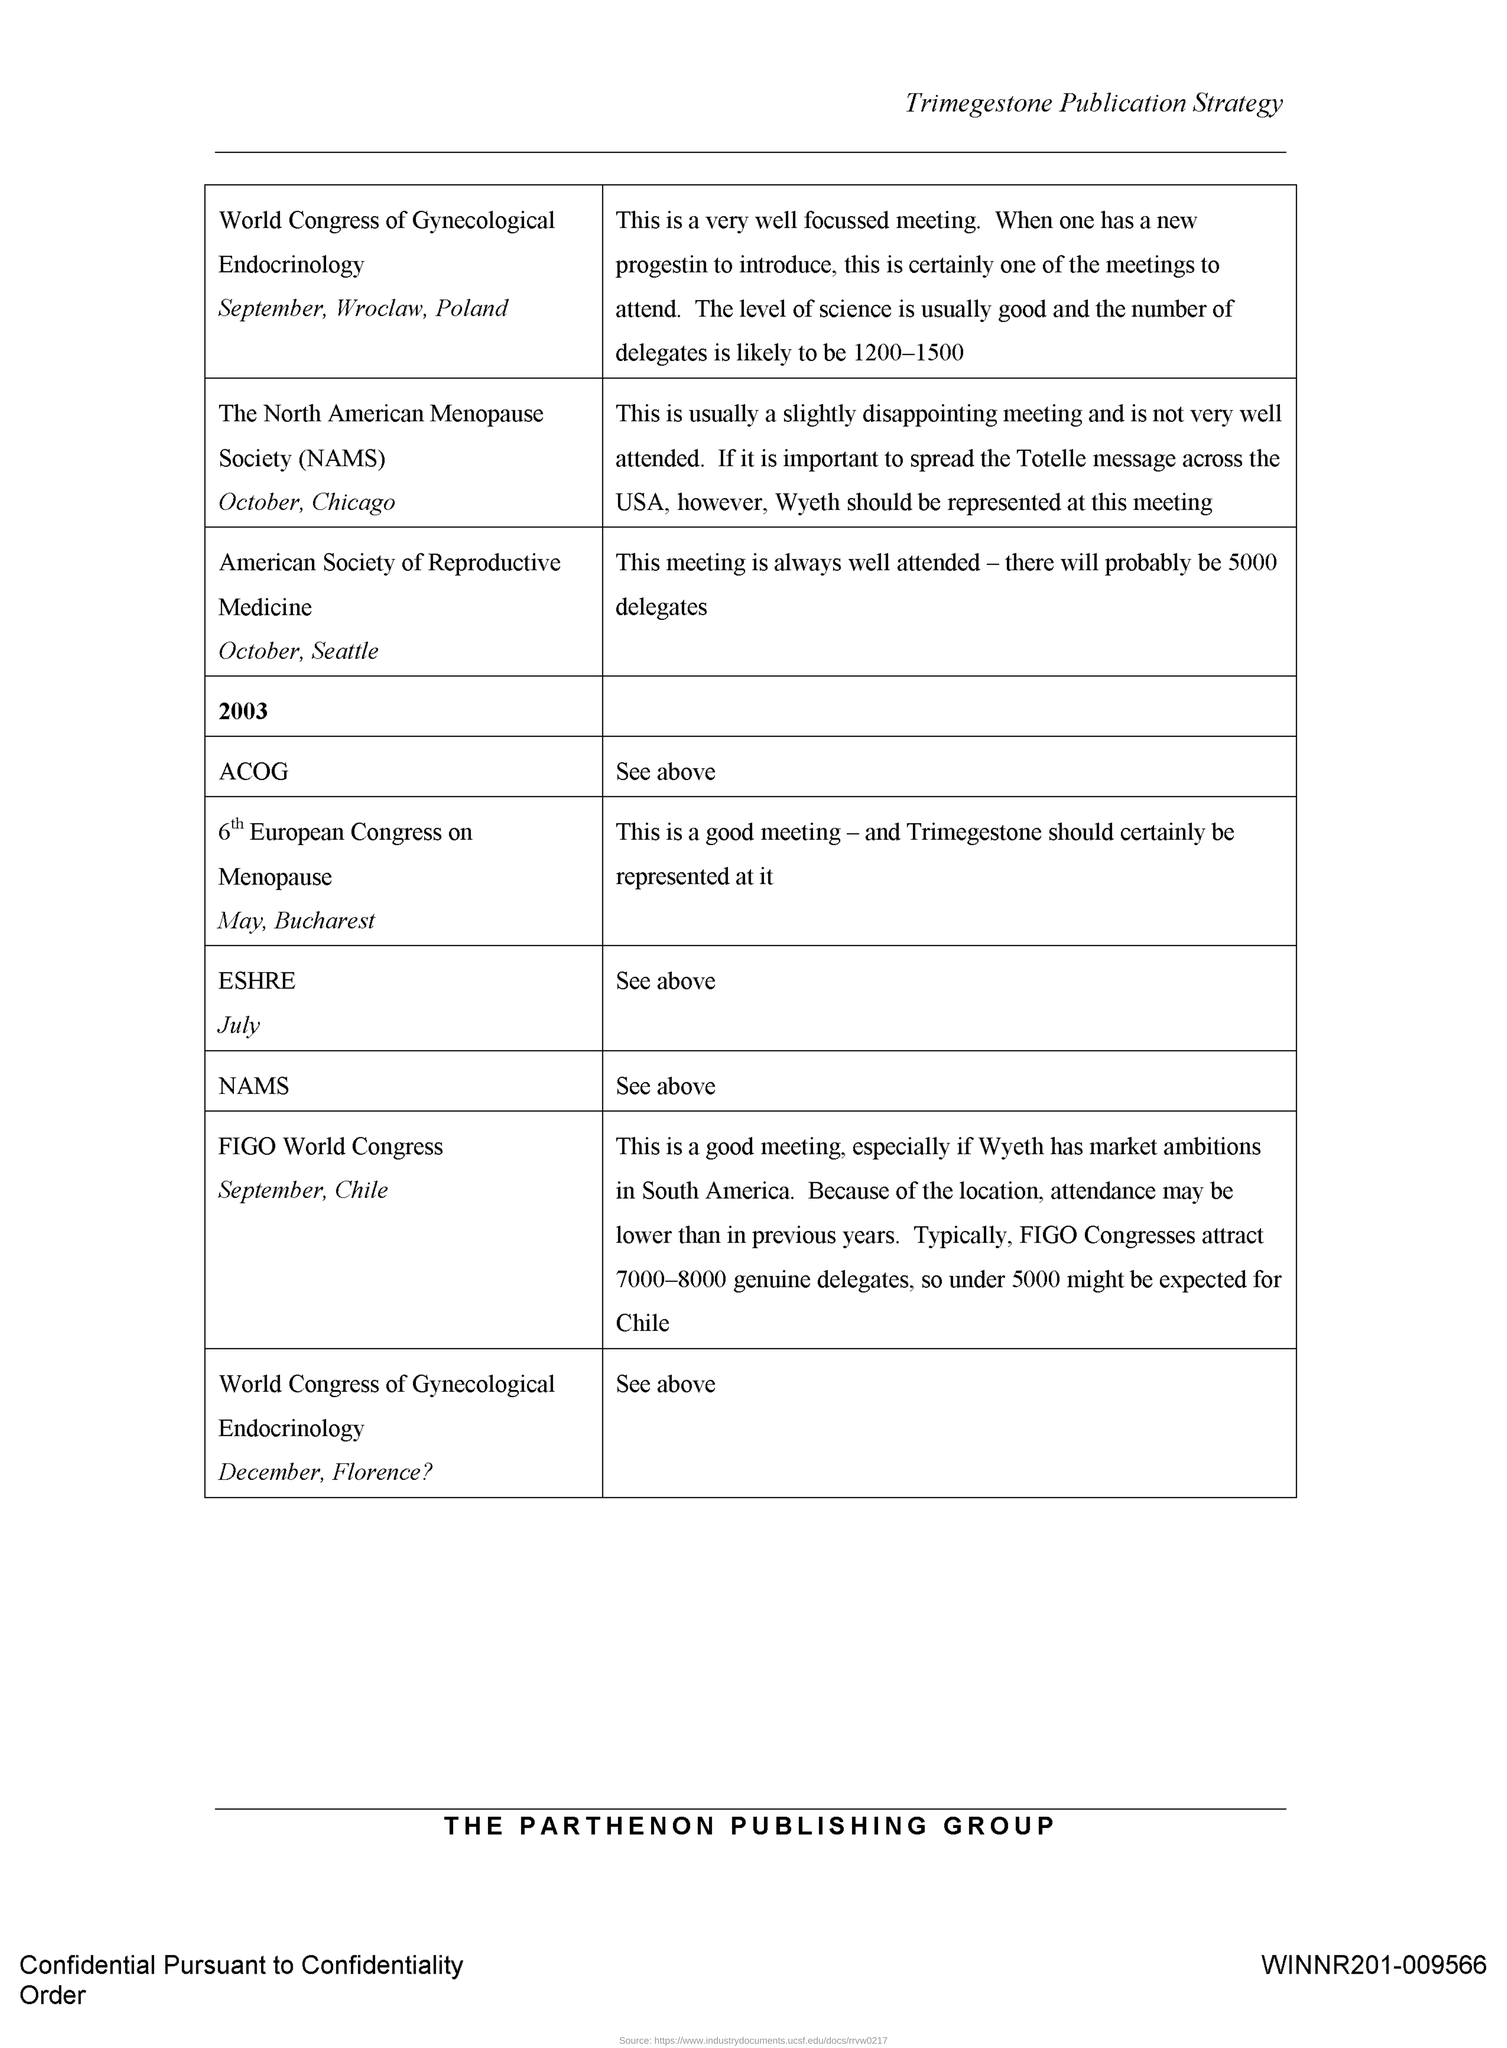Highlight a few significant elements in this photo. The document in question is titled 'Trimegestone Publication Strategy.' 